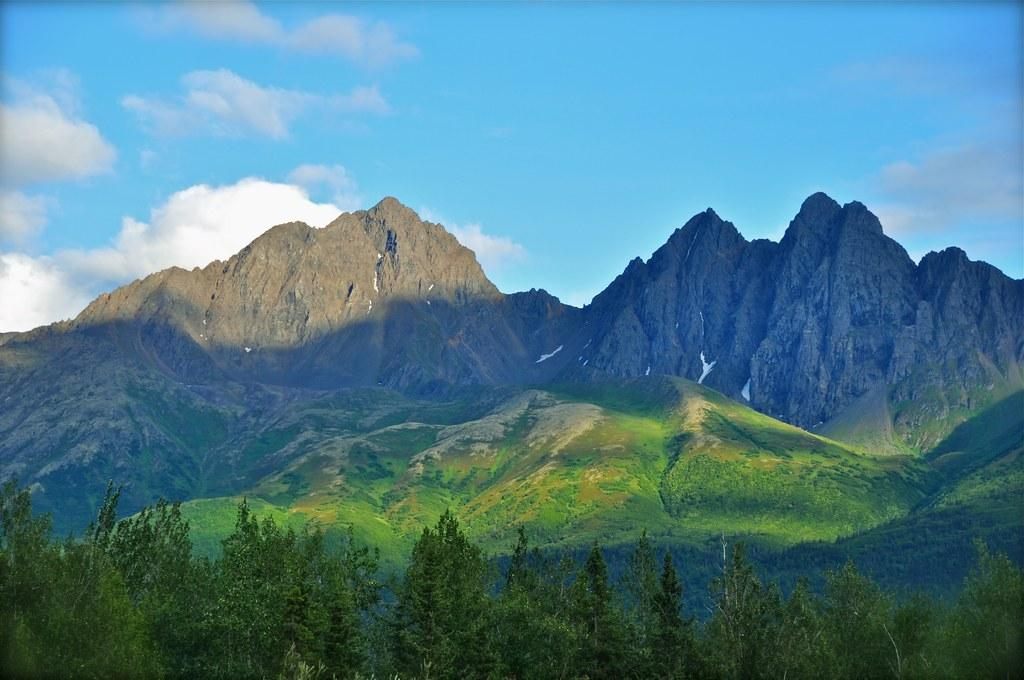What type of scenery is shown in the image? The image depicts a beautiful scenery. What can be seen in the image besides the scenery? There are many trees and grass in the image. Where is the scenery located? The scenery is on mountains. What can be seen in the background of the image? In the background, there are two huge mountains. What is the condition of the mountains in the image? The mountains are filled with mud. How would you describe the climate in the image? The climate in the image is pleasant. Are there any bats flying around in the image? There are no bats visible in the image. What type of metal can be seen on the mountains in the image? There is no metal present on the mountains in the image. 